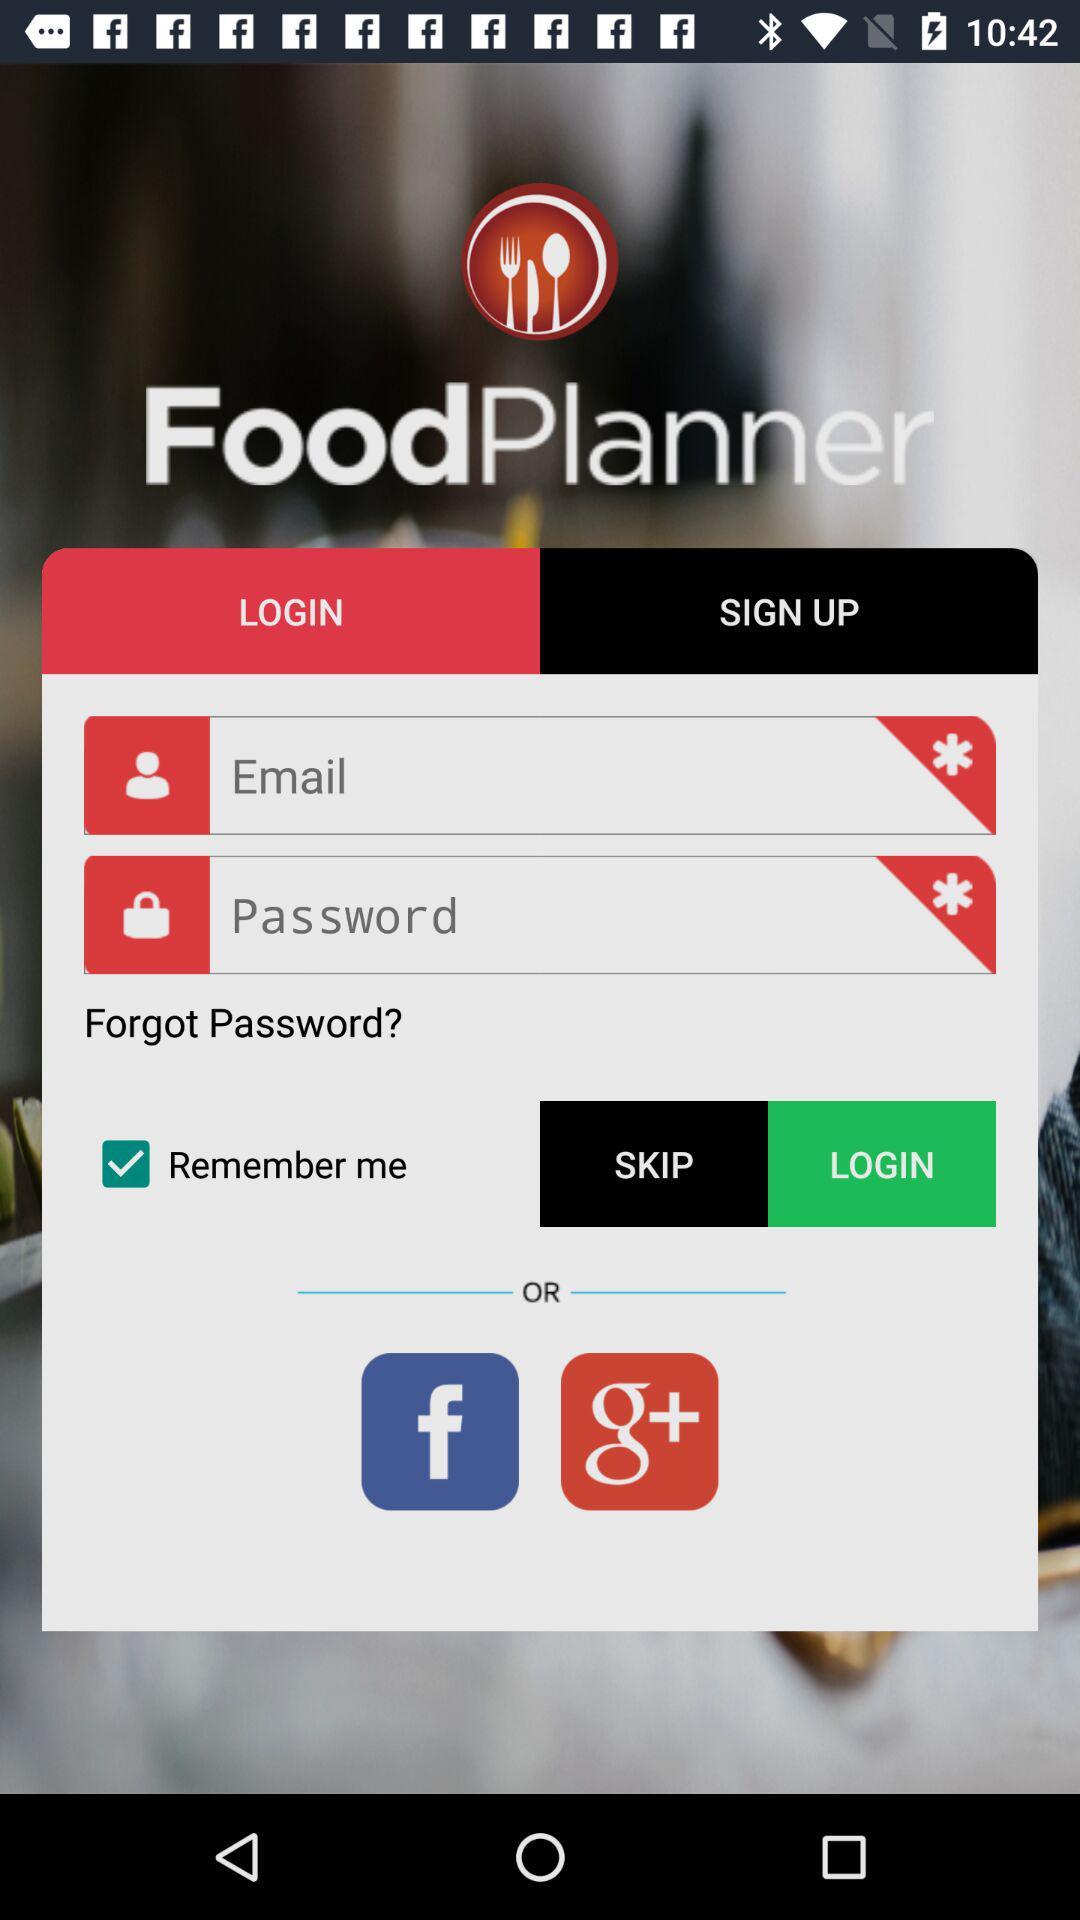What are the applications that can be used to login? The applications are "Facebook" and "Google+". 